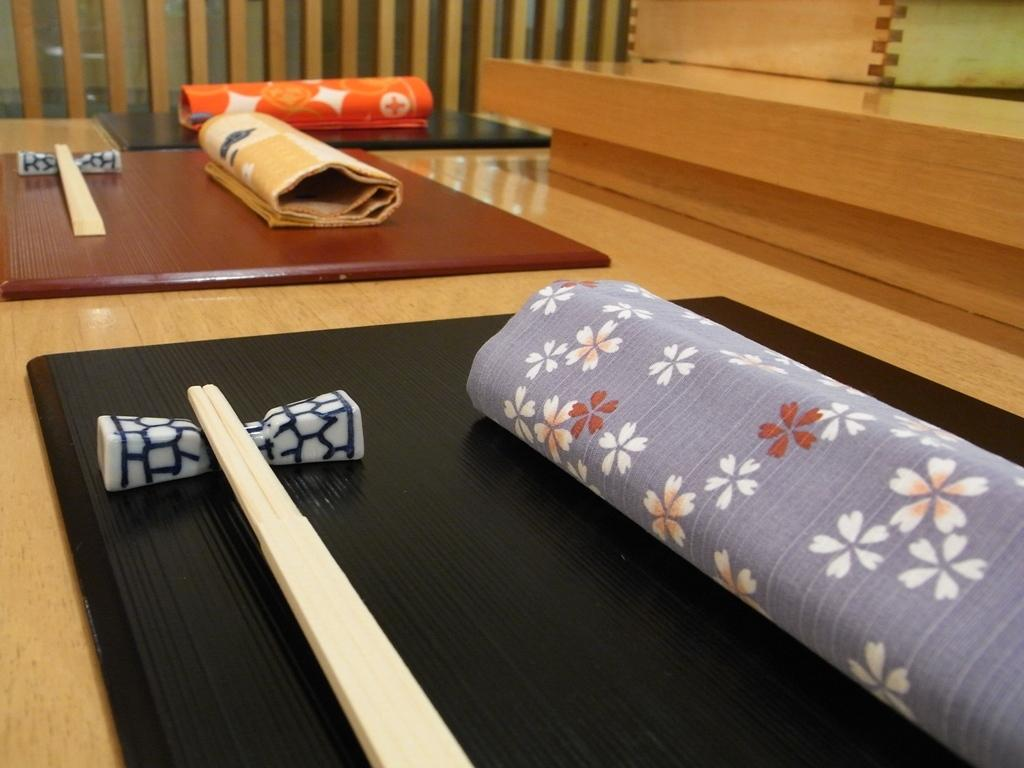What type of furniture is in the image? There is a table in the image. What is covering the table? There is a cloth on the table. What utensils can be seen on the table? Chopsticks are present on the table. What time of day is it in the image, and what cast of characters is present? The time of day and cast of characters cannot be determined from the image, as it only shows a table with a cloth and chopsticks. 